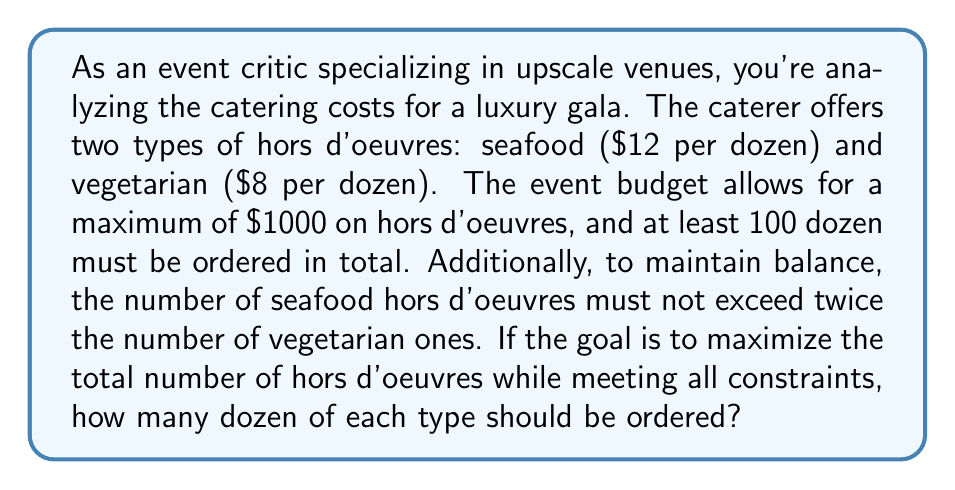Could you help me with this problem? Let's approach this step-by-step using a system of inequalities:

1) Let $x$ be the number of dozen seafood hors d'oeuvres and $y$ be the number of dozen vegetarian hors d'oeuvres.

2) We can set up the following inequalities based on the given constraints:

   Budget constraint: $12x + 8y \leq 1000$
   Minimum order: $x + y \geq 100$
   Balance constraint: $x \leq 2y$
   Non-negativity: $x \geq 0, y \geq 0$

3) Our objective is to maximize $x + y$, the total number of dozens ordered.

4) We can solve this graphically or using linear programming. Let's use the graphical method:

5) Plot the inequalities:
   
   [asy]
   import graph;
   size(200,200);
   xaxis("x",0,100);
   yaxis("y",0,100);
   draw((0,125)--(83.33,0),rgb(0,0,1));
   draw((100,0)--(0,100),rgb(1,0,0));
   draw((0,0)--(100,50),rgb(0,1,0));
   fill((0,50)--(41.67,50)--(83.33,8.33)--(50,25)--(0,50),rgb(0.5,0.5,0.5));
   label("$12x+8y=1000$",(60,30),E);
   label("$x+y=100$",(40,70),NW);
   label("$x=2y$",(80,40),E);
   [/asy]

6) The feasible region is the shaded area. The optimal solution will be at one of the corner points.

7) The corner points are approximately:
   (0, 50), (41.67, 50), (83.33, 8.33), (50, 25)

8) Evaluating $x + y$ at these points:
   (0, 50): 0 + 50 = 50
   (41.67, 50): 41.67 + 50 = 91.67
   (83.33, 8.33): 83.33 + 8.33 = 91.66
   (50, 25): 50 + 25 = 75

9) The maximum is at (41.67, 50), which rounded to whole numbers is (42, 50).

Therefore, to maximize the total number of hors d'oeuvres, the event should order 42 dozen seafood and 50 dozen vegetarian hors d'oeuvres.
Answer: 42 dozen seafood, 50 dozen vegetarian 